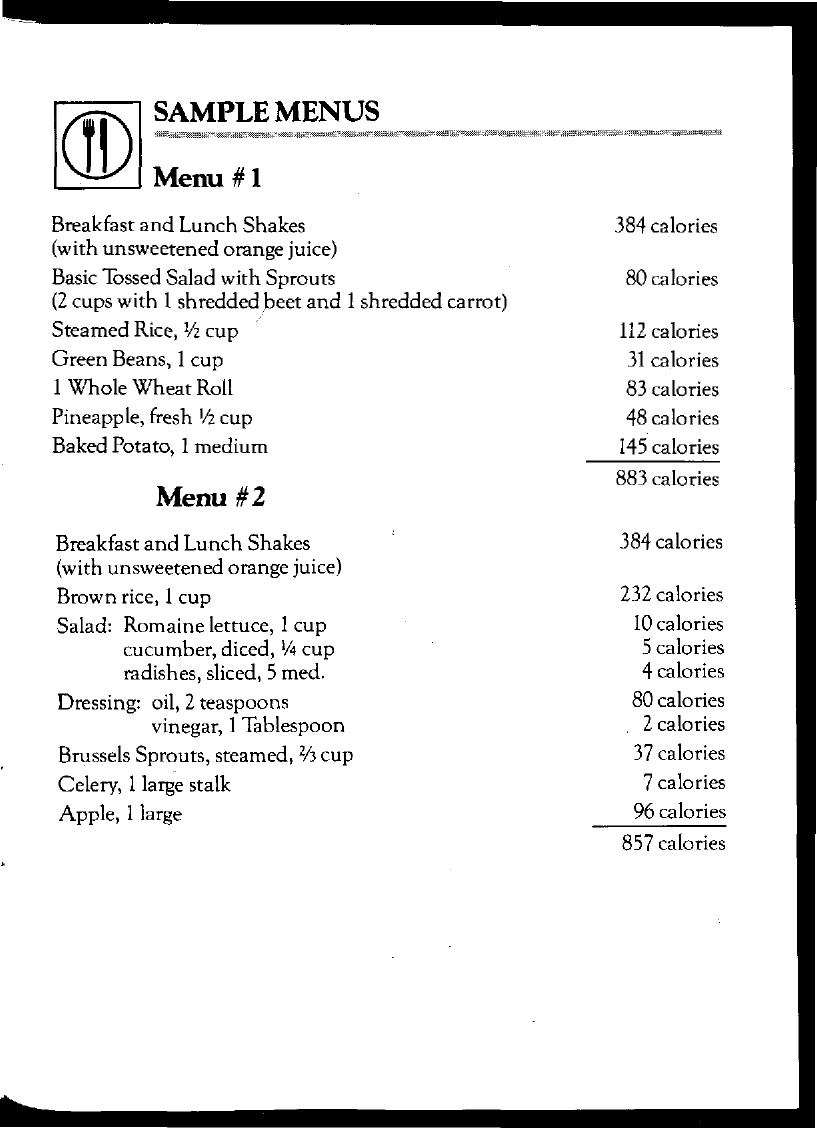List a handful of essential elements in this visual. The document title is 'SAMPLE MENUS.' A large apple contains 96 calories. The total amount of calories in Menu #1 is 883 calories. 